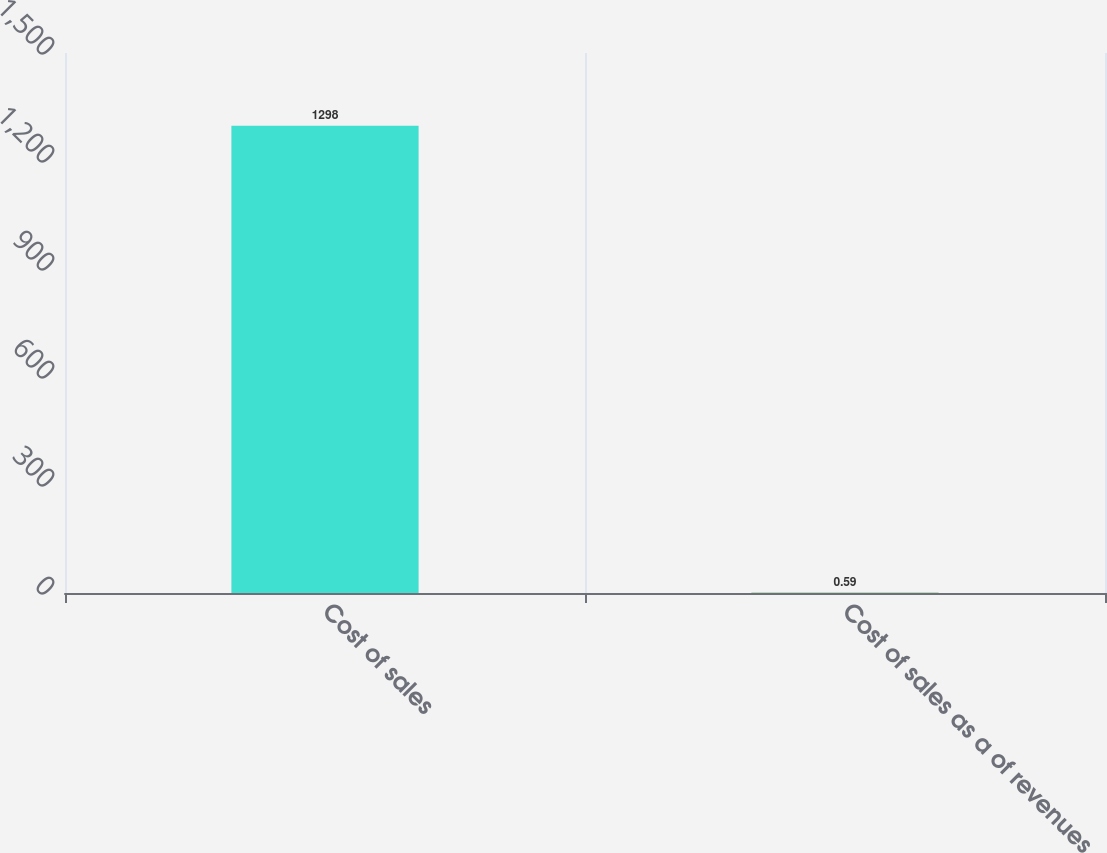Convert chart. <chart><loc_0><loc_0><loc_500><loc_500><bar_chart><fcel>Cost of sales<fcel>Cost of sales as a of revenues<nl><fcel>1298<fcel>0.59<nl></chart> 